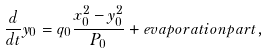Convert formula to latex. <formula><loc_0><loc_0><loc_500><loc_500>\frac { d } { d t } y _ { 0 } = q _ { 0 } \frac { x _ { 0 } ^ { 2 } - y _ { 0 } ^ { 2 } } { P _ { 0 } } + e v a p o r a t i o n p a r t ,</formula> 